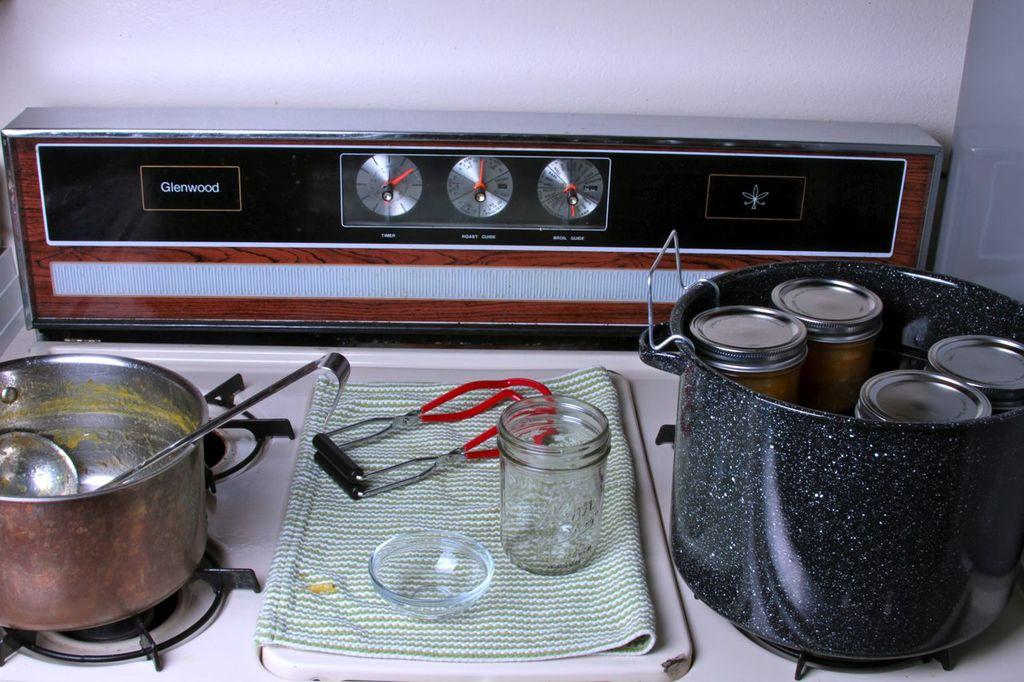<image>
Summarize the visual content of the image. an oven that has the word Glenwood on it 